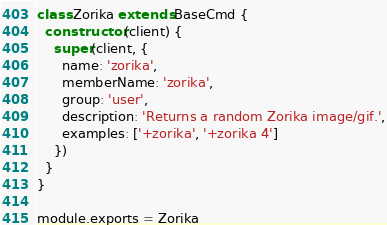<code> <loc_0><loc_0><loc_500><loc_500><_JavaScript_>class Zorika extends BaseCmd {
  constructor (client) {
    super(client, {
      name: 'zorika',
      memberName: 'zorika',
      group: 'user',
      description: 'Returns a random Zorika image/gif.',
      examples: ['+zorika', '+zorika 4']
    })
  }
}

module.exports = Zorika
</code> 